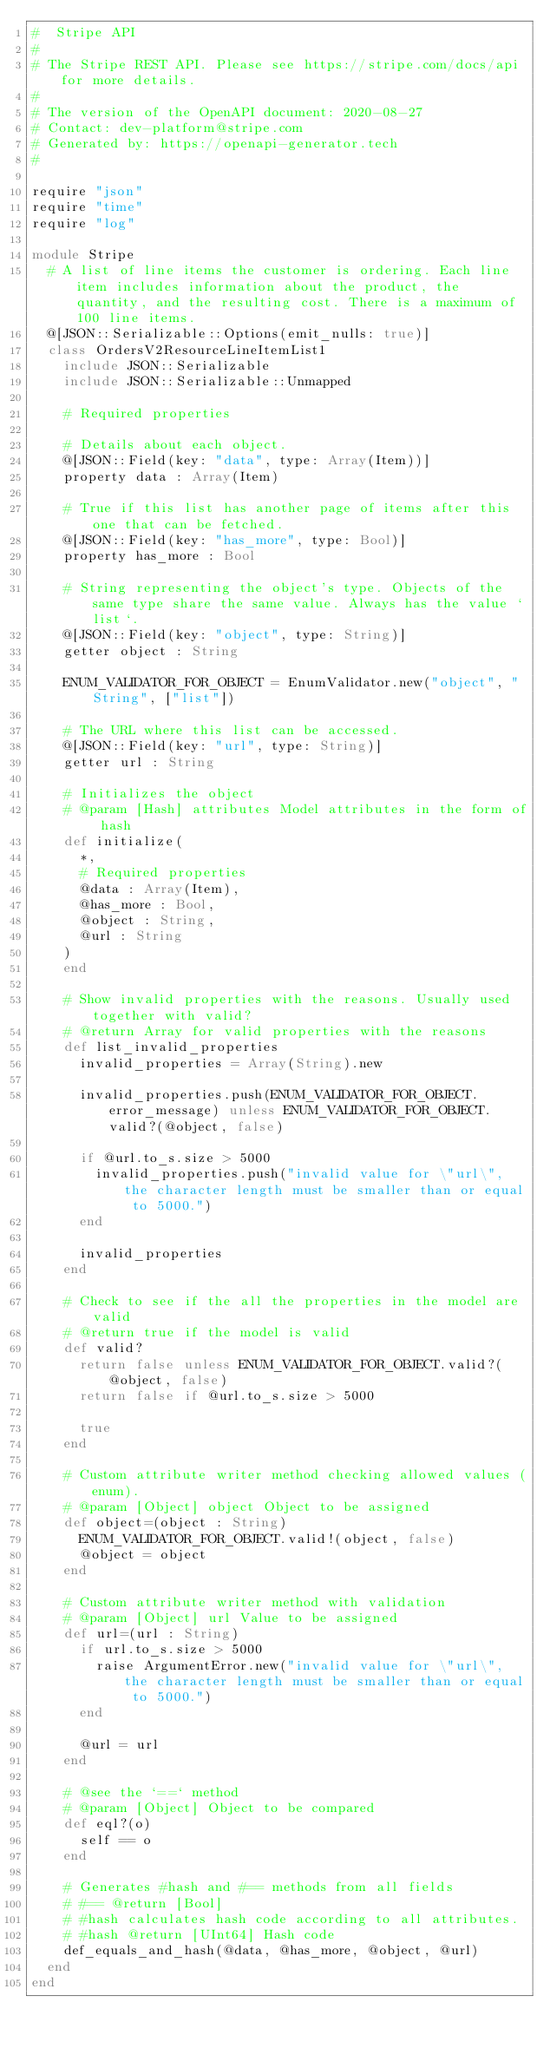Convert code to text. <code><loc_0><loc_0><loc_500><loc_500><_Crystal_>#  Stripe API
#
# The Stripe REST API. Please see https://stripe.com/docs/api for more details.
#
# The version of the OpenAPI document: 2020-08-27
# Contact: dev-platform@stripe.com
# Generated by: https://openapi-generator.tech
#

require "json"
require "time"
require "log"

module Stripe
  # A list of line items the customer is ordering. Each line item includes information about the product, the quantity, and the resulting cost. There is a maximum of 100 line items.
  @[JSON::Serializable::Options(emit_nulls: true)]
  class OrdersV2ResourceLineItemList1
    include JSON::Serializable
    include JSON::Serializable::Unmapped

    # Required properties

    # Details about each object.
    @[JSON::Field(key: "data", type: Array(Item))]
    property data : Array(Item)

    # True if this list has another page of items after this one that can be fetched.
    @[JSON::Field(key: "has_more", type: Bool)]
    property has_more : Bool

    # String representing the object's type. Objects of the same type share the same value. Always has the value `list`.
    @[JSON::Field(key: "object", type: String)]
    getter object : String

    ENUM_VALIDATOR_FOR_OBJECT = EnumValidator.new("object", "String", ["list"])

    # The URL where this list can be accessed.
    @[JSON::Field(key: "url", type: String)]
    getter url : String

    # Initializes the object
    # @param [Hash] attributes Model attributes in the form of hash
    def initialize(
      *,
      # Required properties
      @data : Array(Item),
      @has_more : Bool,
      @object : String,
      @url : String
    )
    end

    # Show invalid properties with the reasons. Usually used together with valid?
    # @return Array for valid properties with the reasons
    def list_invalid_properties
      invalid_properties = Array(String).new

      invalid_properties.push(ENUM_VALIDATOR_FOR_OBJECT.error_message) unless ENUM_VALIDATOR_FOR_OBJECT.valid?(@object, false)

      if @url.to_s.size > 5000
        invalid_properties.push("invalid value for \"url\", the character length must be smaller than or equal to 5000.")
      end

      invalid_properties
    end

    # Check to see if the all the properties in the model are valid
    # @return true if the model is valid
    def valid?
      return false unless ENUM_VALIDATOR_FOR_OBJECT.valid?(@object, false)
      return false if @url.to_s.size > 5000

      true
    end

    # Custom attribute writer method checking allowed values (enum).
    # @param [Object] object Object to be assigned
    def object=(object : String)
      ENUM_VALIDATOR_FOR_OBJECT.valid!(object, false)
      @object = object
    end

    # Custom attribute writer method with validation
    # @param [Object] url Value to be assigned
    def url=(url : String)
      if url.to_s.size > 5000
        raise ArgumentError.new("invalid value for \"url\", the character length must be smaller than or equal to 5000.")
      end

      @url = url
    end

    # @see the `==` method
    # @param [Object] Object to be compared
    def eql?(o)
      self == o
    end

    # Generates #hash and #== methods from all fields
    # #== @return [Bool]
    # #hash calculates hash code according to all attributes.
    # #hash @return [UInt64] Hash code
    def_equals_and_hash(@data, @has_more, @object, @url)
  end
end
</code> 